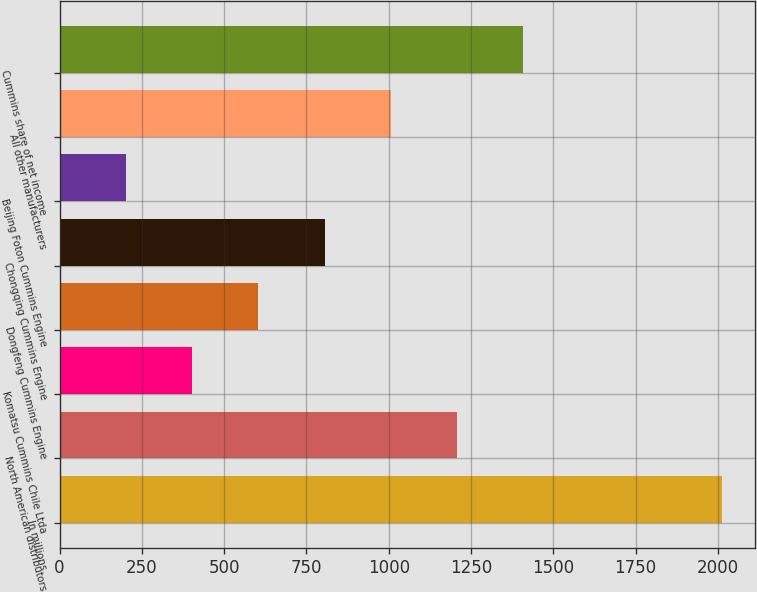Convert chart to OTSL. <chart><loc_0><loc_0><loc_500><loc_500><bar_chart><fcel>In millions<fcel>North American distributors<fcel>Komatsu Cummins Chile Ltda<fcel>Dongfeng Cummins Engine<fcel>Chongqing Cummins Engine<fcel>Beijing Foton Cummins Engine<fcel>All other manufacturers<fcel>Cummins share of net income<nl><fcel>2012<fcel>1207.6<fcel>403.2<fcel>604.3<fcel>805.4<fcel>202.1<fcel>1006.5<fcel>1408.7<nl></chart> 